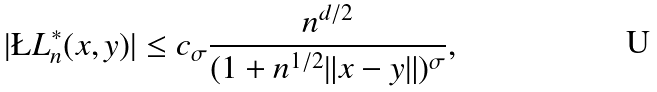Convert formula to latex. <formula><loc_0><loc_0><loc_500><loc_500>| \L L _ { n } ^ { * } ( x , y ) | \leq c _ { \sigma } \frac { n ^ { d / 2 } } { ( 1 + n ^ { 1 / 2 } \| x - y \| ) ^ { \sigma } } ,</formula> 